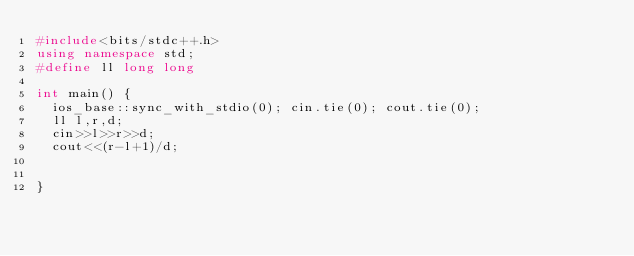Convert code to text. <code><loc_0><loc_0><loc_500><loc_500><_C++_>#include<bits/stdc++.h>
using namespace std;
#define ll long long
 
int main() {
	ios_base::sync_with_stdio(0); cin.tie(0); cout.tie(0);
	ll l,r,d;
	cin>>l>>r>>d;
	cout<<(r-l+1)/d;
	
	
}</code> 